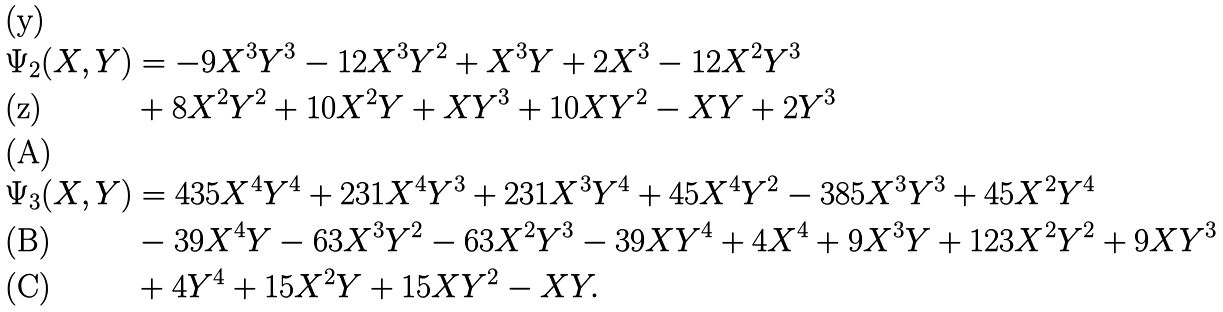<formula> <loc_0><loc_0><loc_500><loc_500>\Psi _ { 2 } ( X , Y ) & = - 9 X ^ { 3 } Y ^ { 3 } - 1 2 X ^ { 3 } Y ^ { 2 } + X ^ { 3 } Y + 2 X ^ { 3 } - 1 2 X ^ { 2 } Y ^ { 3 } \\ & + 8 X ^ { 2 } Y ^ { 2 } + 1 0 X ^ { 2 } Y + X Y ^ { 3 } + 1 0 X Y ^ { 2 } - X Y + 2 Y ^ { 3 } \\ \Psi _ { 3 } ( X , Y ) & = 4 3 5 X ^ { 4 } Y ^ { 4 } + 2 3 1 X ^ { 4 } Y ^ { 3 } + 2 3 1 X ^ { 3 } Y ^ { 4 } + 4 5 X ^ { 4 } Y ^ { 2 } - 3 8 5 X ^ { 3 } Y ^ { 3 } + 4 5 X ^ { 2 } Y ^ { 4 } \\ & - 3 9 X ^ { 4 } Y - 6 3 X ^ { 3 } Y ^ { 2 } - 6 3 X ^ { 2 } Y ^ { 3 } - 3 9 X Y ^ { 4 } + 4 X ^ { 4 } + 9 X ^ { 3 } Y + 1 2 3 X ^ { 2 } Y ^ { 2 } + 9 X Y ^ { 3 } \\ & + 4 Y ^ { 4 } + 1 5 X ^ { 2 } Y + 1 5 X Y ^ { 2 } - X Y .</formula> 